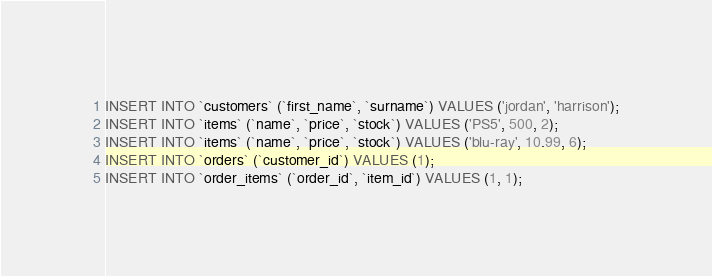<code> <loc_0><loc_0><loc_500><loc_500><_SQL_>INSERT INTO `customers` (`first_name`, `surname`) VALUES ('jordan', 'harrison');
INSERT INTO `items` (`name`, `price`, `stock`) VALUES ('PS5', 500, 2);
INSERT INTO `items` (`name`, `price`, `stock`) VALUES ('blu-ray', 10.99, 6);
INSERT INTO `orders` (`customer_id`) VALUES (1);
INSERT INTO `order_items` (`order_id`, `item_id`) VALUES (1, 1);</code> 